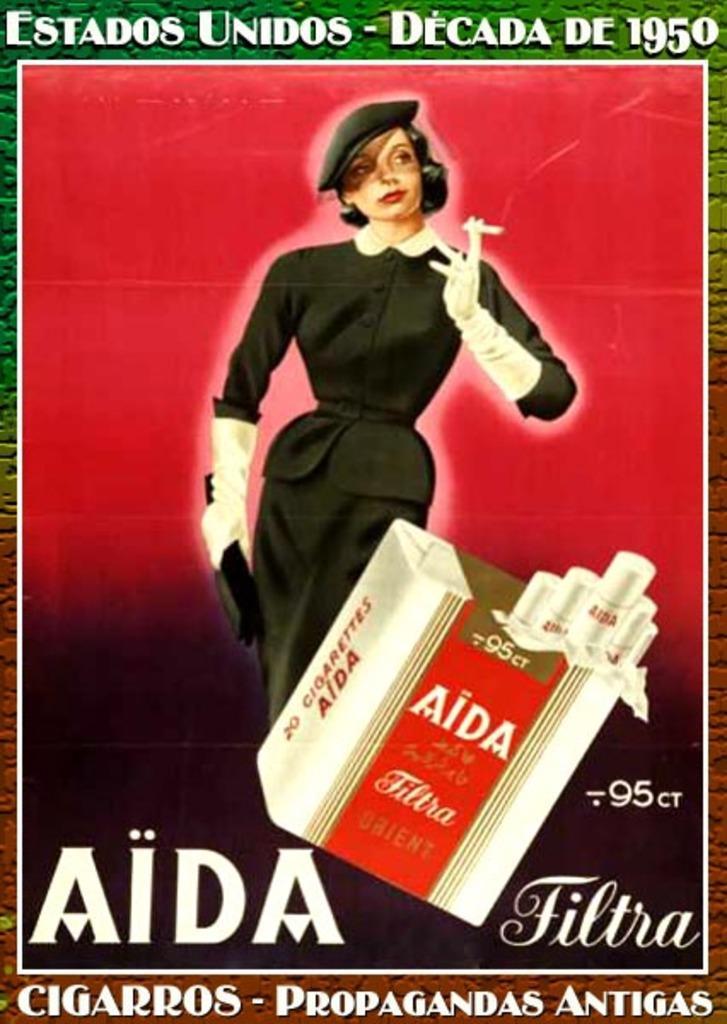How would you summarize this image in a sentence or two? In this image there is a poster of a woman and a box and some text on it. Woman is holding a cigarette in her hand. Box is having few cigarettes in it. Bottom of image there is some text. 